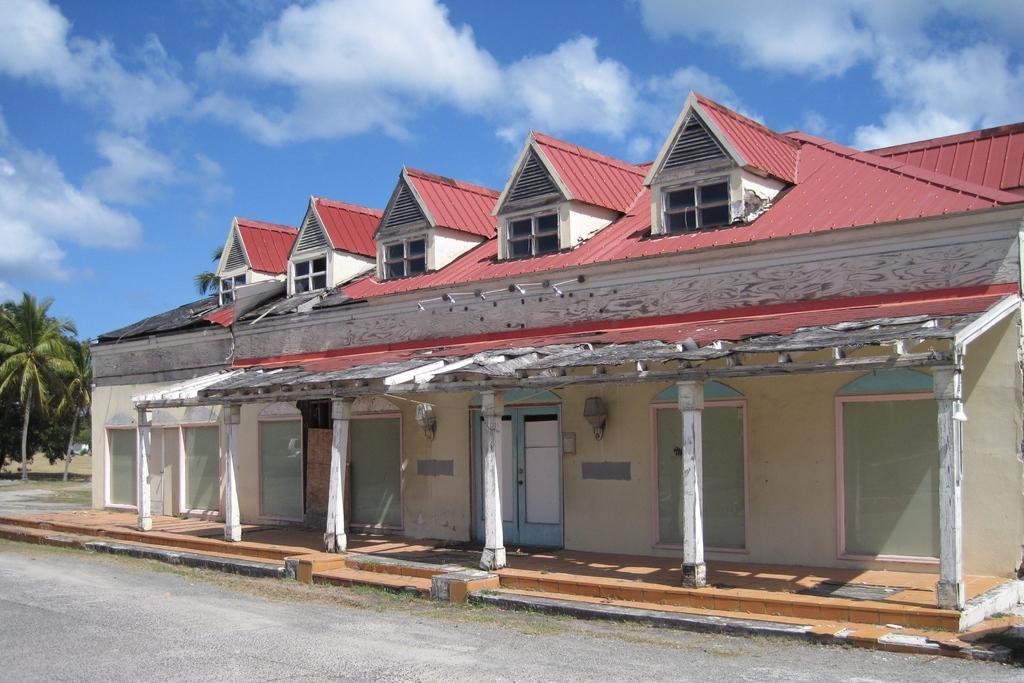Please provide a concise description of this image. In this image we can see a house with doors, pillars and red color roof, here we can see the road, trees and the blue color sky with clouds in the background. 